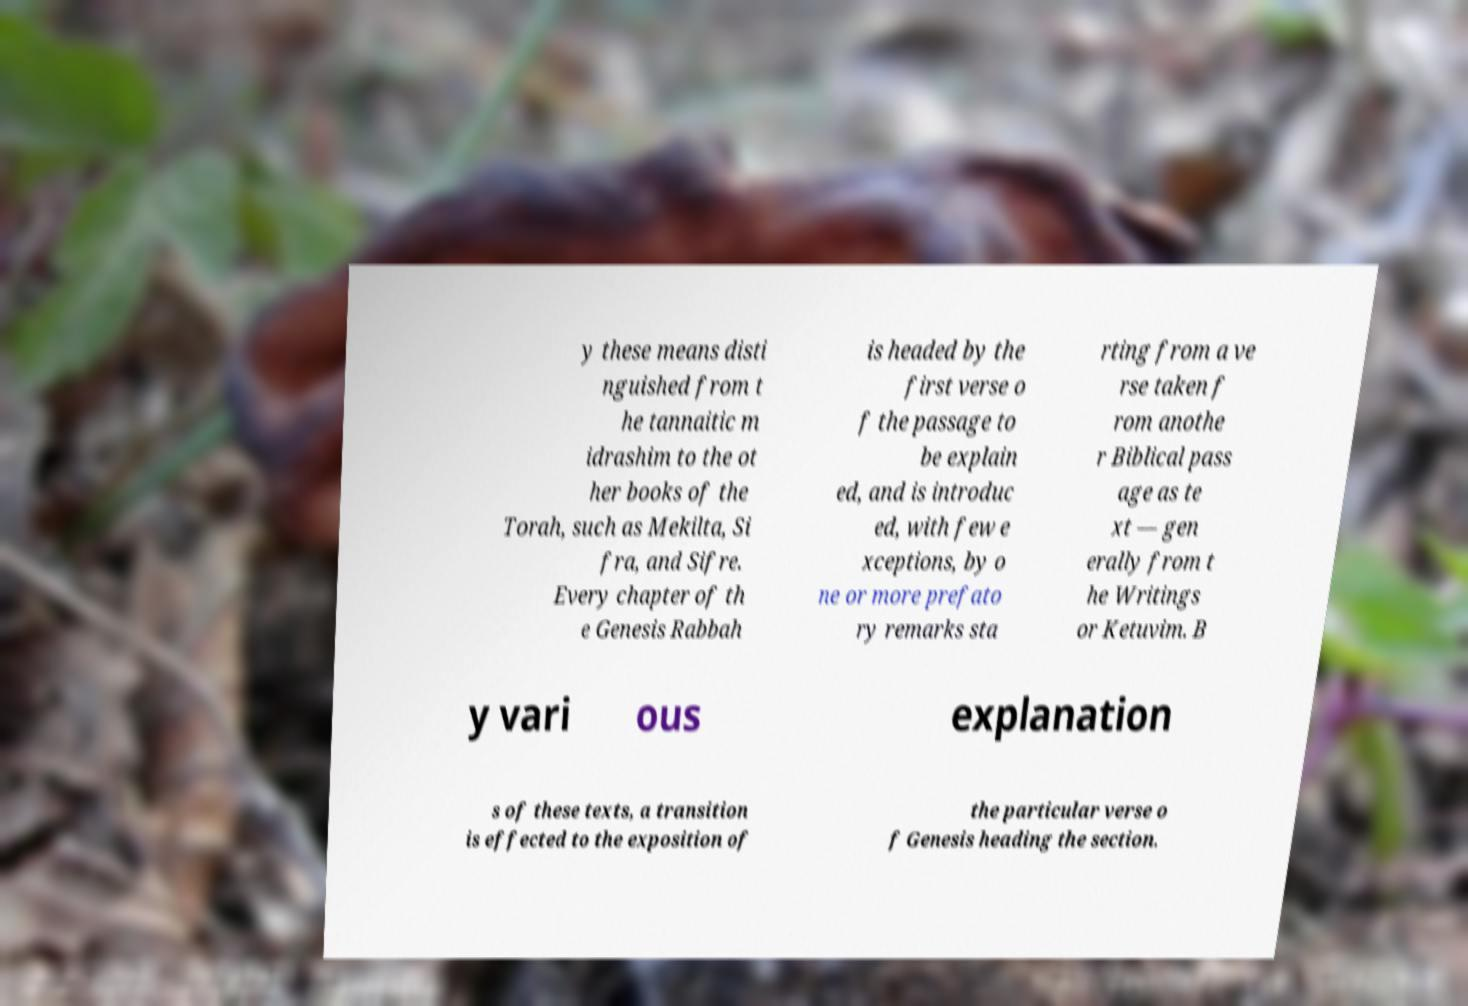I need the written content from this picture converted into text. Can you do that? y these means disti nguished from t he tannaitic m idrashim to the ot her books of the Torah, such as Mekilta, Si fra, and Sifre. Every chapter of th e Genesis Rabbah is headed by the first verse o f the passage to be explain ed, and is introduc ed, with few e xceptions, by o ne or more prefato ry remarks sta rting from a ve rse taken f rom anothe r Biblical pass age as te xt — gen erally from t he Writings or Ketuvim. B y vari ous explanation s of these texts, a transition is effected to the exposition of the particular verse o f Genesis heading the section. 